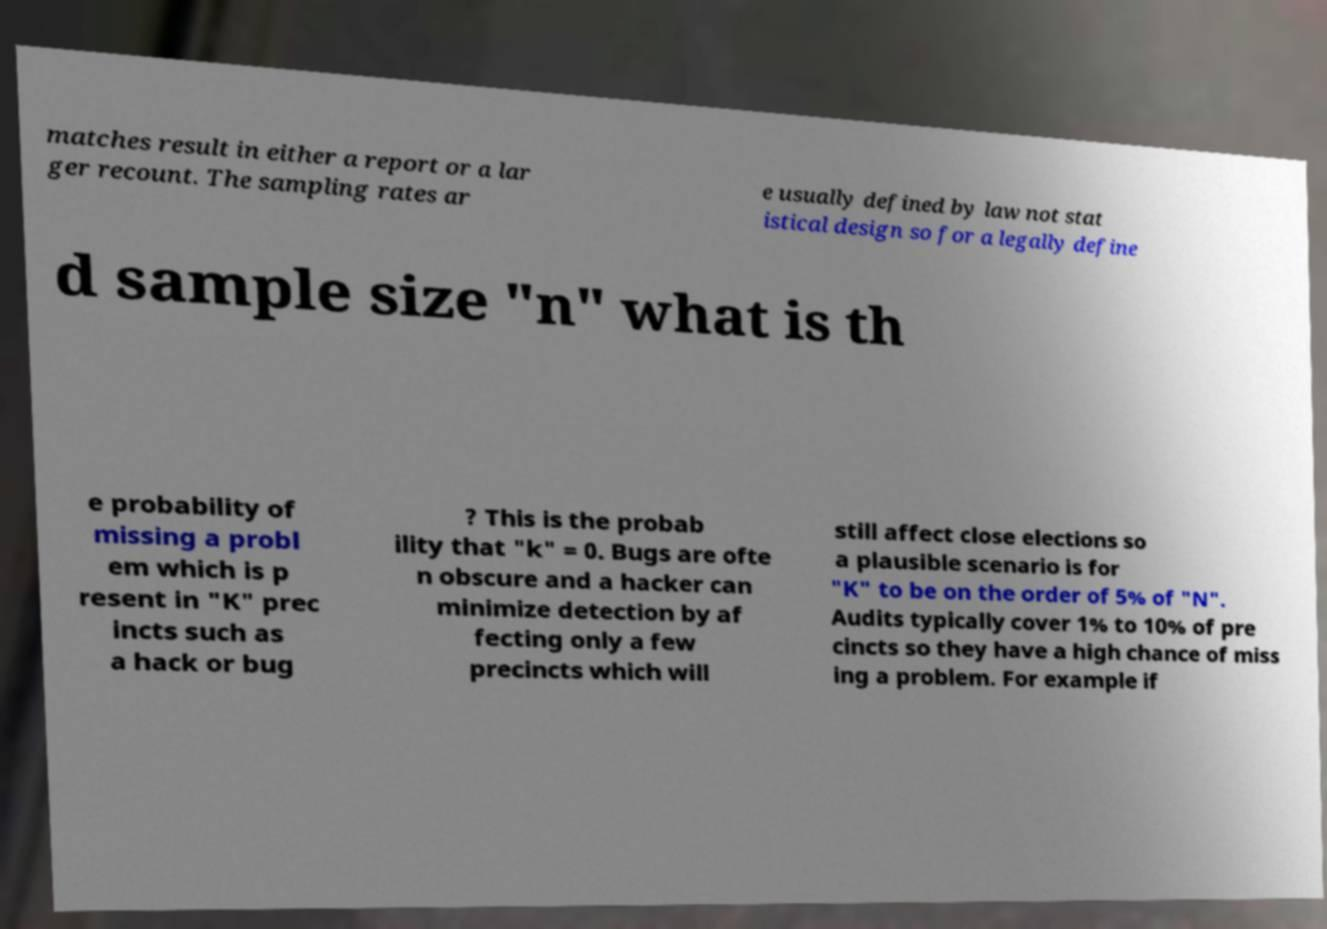Could you assist in decoding the text presented in this image and type it out clearly? matches result in either a report or a lar ger recount. The sampling rates ar e usually defined by law not stat istical design so for a legally define d sample size "n" what is th e probability of missing a probl em which is p resent in "K" prec incts such as a hack or bug ? This is the probab ility that "k" = 0. Bugs are ofte n obscure and a hacker can minimize detection by af fecting only a few precincts which will still affect close elections so a plausible scenario is for "K" to be on the order of 5% of "N". Audits typically cover 1% to 10% of pre cincts so they have a high chance of miss ing a problem. For example if 